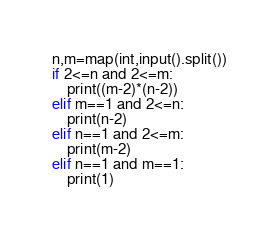<code> <loc_0><loc_0><loc_500><loc_500><_Python_>n,m=map(int,input().split())
if 2<=n and 2<=m:
    print((m-2)*(n-2))
elif m==1 and 2<=n:
    print(n-2)
elif n==1 and 2<=m:
    print(m-2)
elif n==1 and m==1:
    print(1)

</code> 